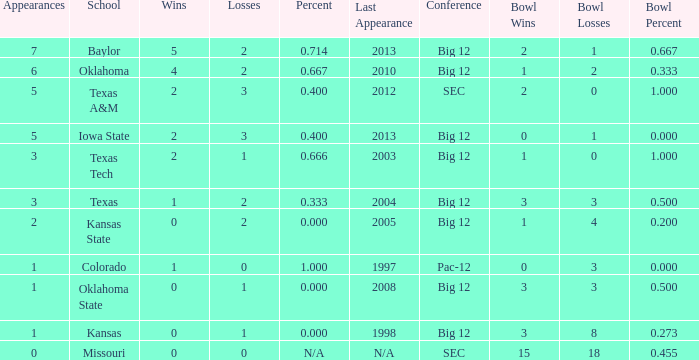How many wins did Baylor have?  1.0. 